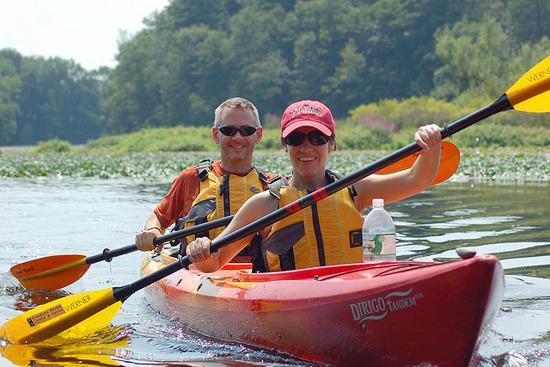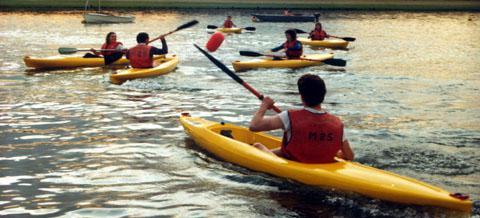The first image is the image on the left, the second image is the image on the right. Considering the images on both sides, is "One image shows only rowers in red kayaks." valid? Answer yes or no. Yes. 